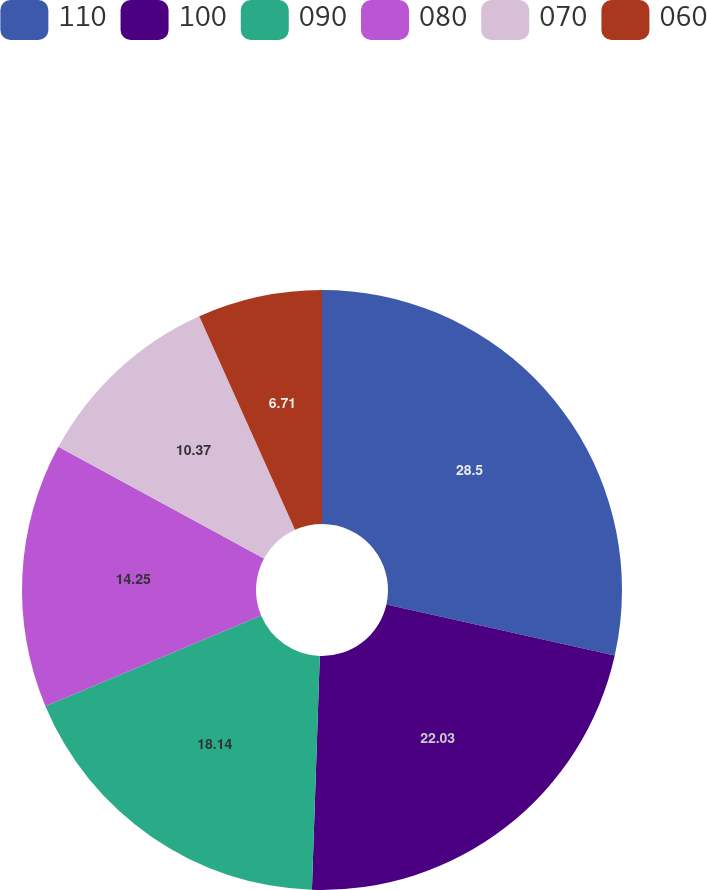<chart> <loc_0><loc_0><loc_500><loc_500><pie_chart><fcel>110<fcel>100<fcel>090<fcel>080<fcel>070<fcel>060<nl><fcel>28.51%<fcel>22.03%<fcel>18.14%<fcel>14.25%<fcel>10.37%<fcel>6.71%<nl></chart> 